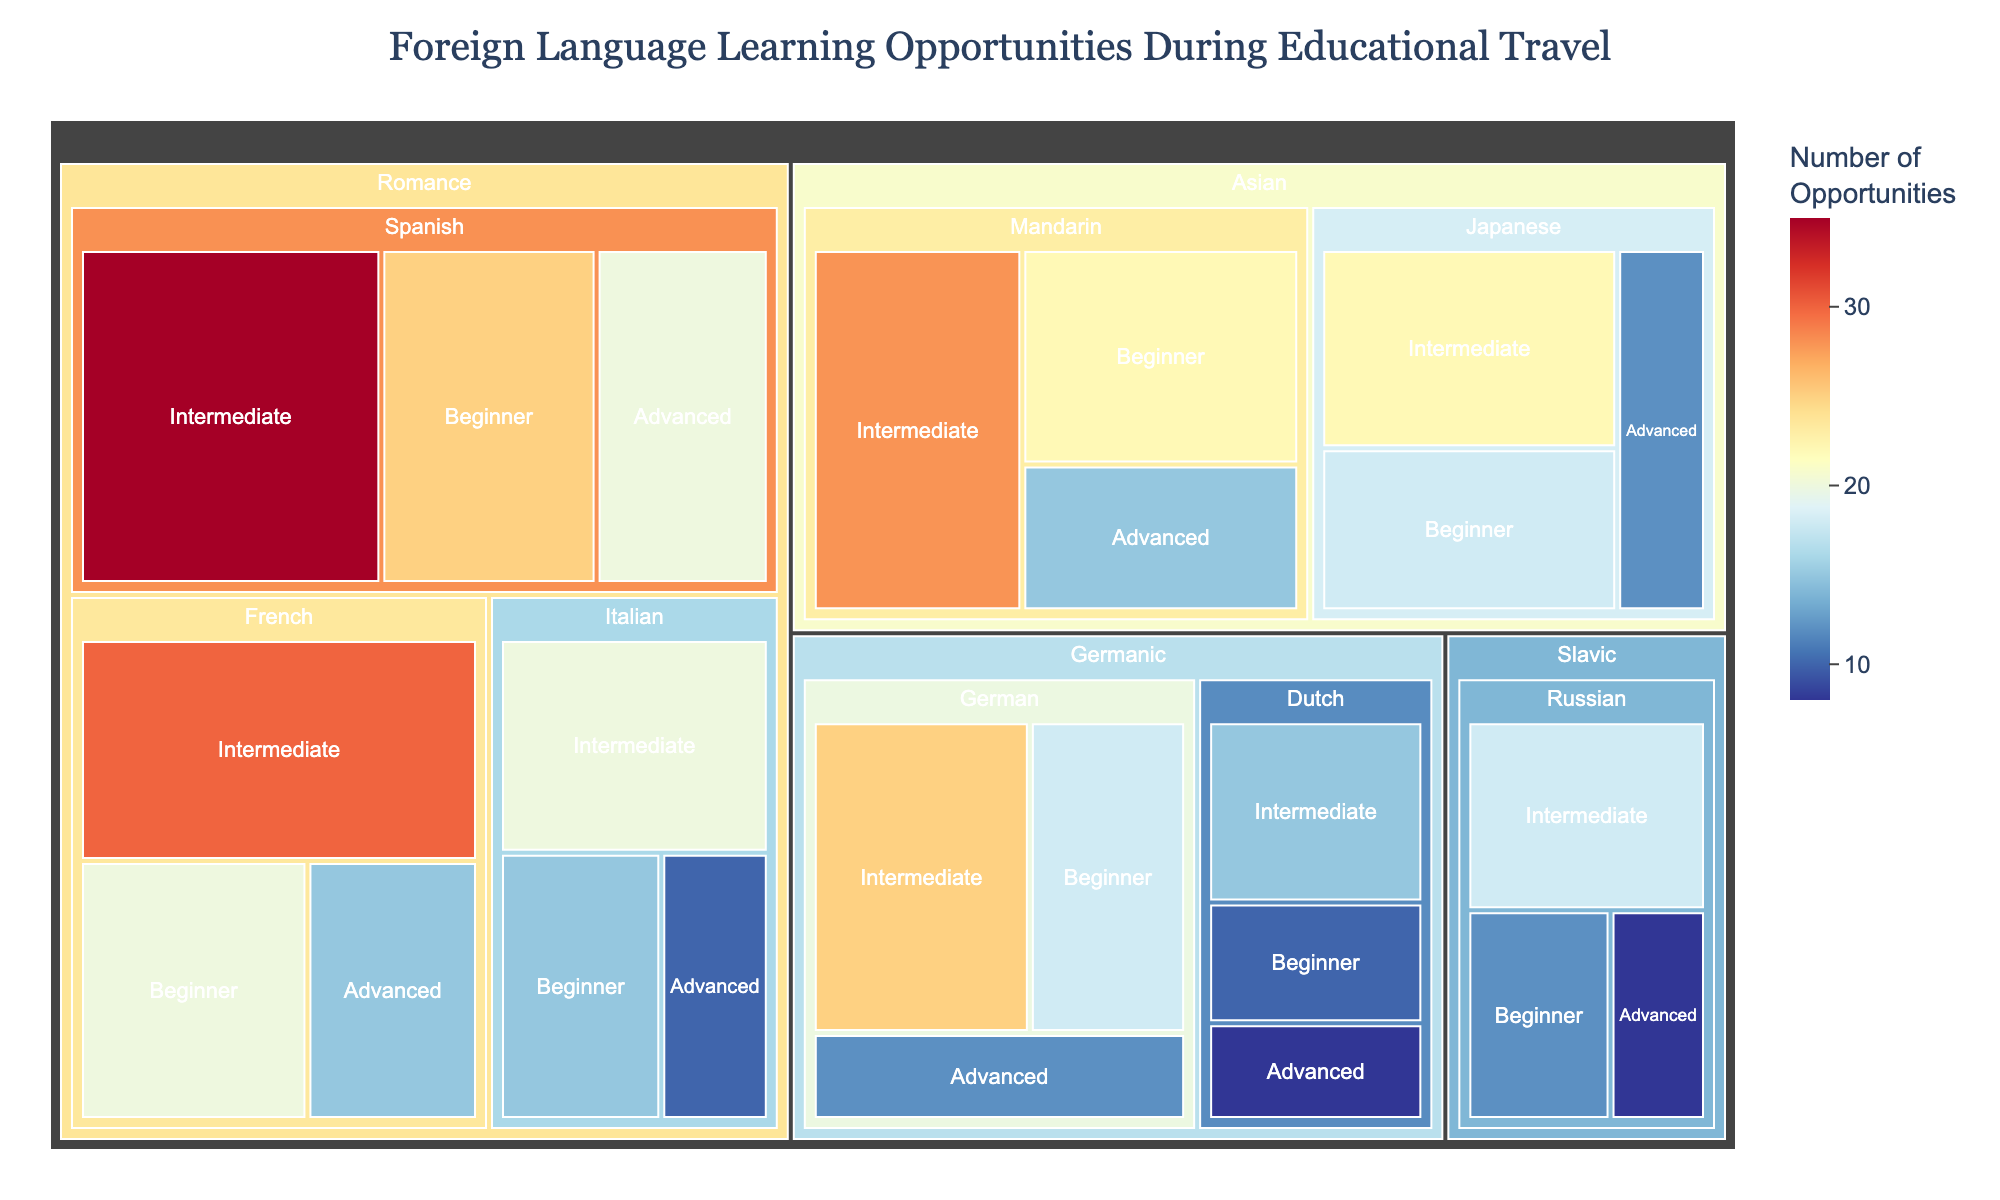What is the title of the Treemap? The title of the Treemap is typically displayed prominently at the top center of the plot, allowing easy identification of the figure's subject.
Answer: Foreign Language Learning Opportunities During Educational Travel Which Romance language has the most opportunities for the beginner level? To find this, locate the Romance language family in the Treemap, then identify the beginner sections for each language within this family and compare their values.
Answer: Spanish What is the total number of opportunities for the Germanic language family? To find the total, sum the opportunities for each proficiency level of all languages within the Germanic language family. For German: 18 + 25 + 12 = 55; For Dutch: 10 + 15 + 8 = 33; Total = 55 + 33 = 88.
Answer: 88 How does the number of advanced opportunities for Japanese compare to those for Mandarin? Locate the 'Advanced' sections within the 'Japanese' and 'Mandarin' categories and compare the values directly from the Treemap.
Answer: Japanese has fewer advanced opportunities (12) compared to Mandarin (15) Which language within the Slavic family offers the highest number of intermediate opportunities? By evaluating the 'Intermediate' sections within the Slavic family segment for both languages, you can identify which has the highest number.
Answer: Russian What is the difference in the number of beginner opportunities between Italian and German? Find the beginner opportunities for both languages (Italian: 15, German: 18) and subtract the smaller number from the larger. Difference = 18 - 15.
Answer: 3 If you combine the total opportunities for French and Italian, how does it compare to the total opportunities for German and Dutch? Sum the opportunities for French (20+30+15=65) and Italian (15+20+10=45), which equals 110. For German (18+25+12=55) and Dutch (10+15+8=33), which equals 88. Compare these totals.
Answer: French and Italian have more opportunities (110) than German and Dutch (88) Which proficiency level generally offers the most opportunities across the Romance family? By observing the sizes of the sections for each proficiency level within the Romance family, identify which level appears to have the largest cumulative area.
Answer: Intermediate What's the average number of opportunities for the advanced proficiency level across all languages? Sum the opportunities for the advanced level for each language: Spanish (20), French (15), Italian (10), German (12), Dutch (8), Russian (8), Mandarin (15), Japanese (12). Total advanced opportunities = 100. Number of languages = 8. Average = 100/8.
Answer: 12.5 